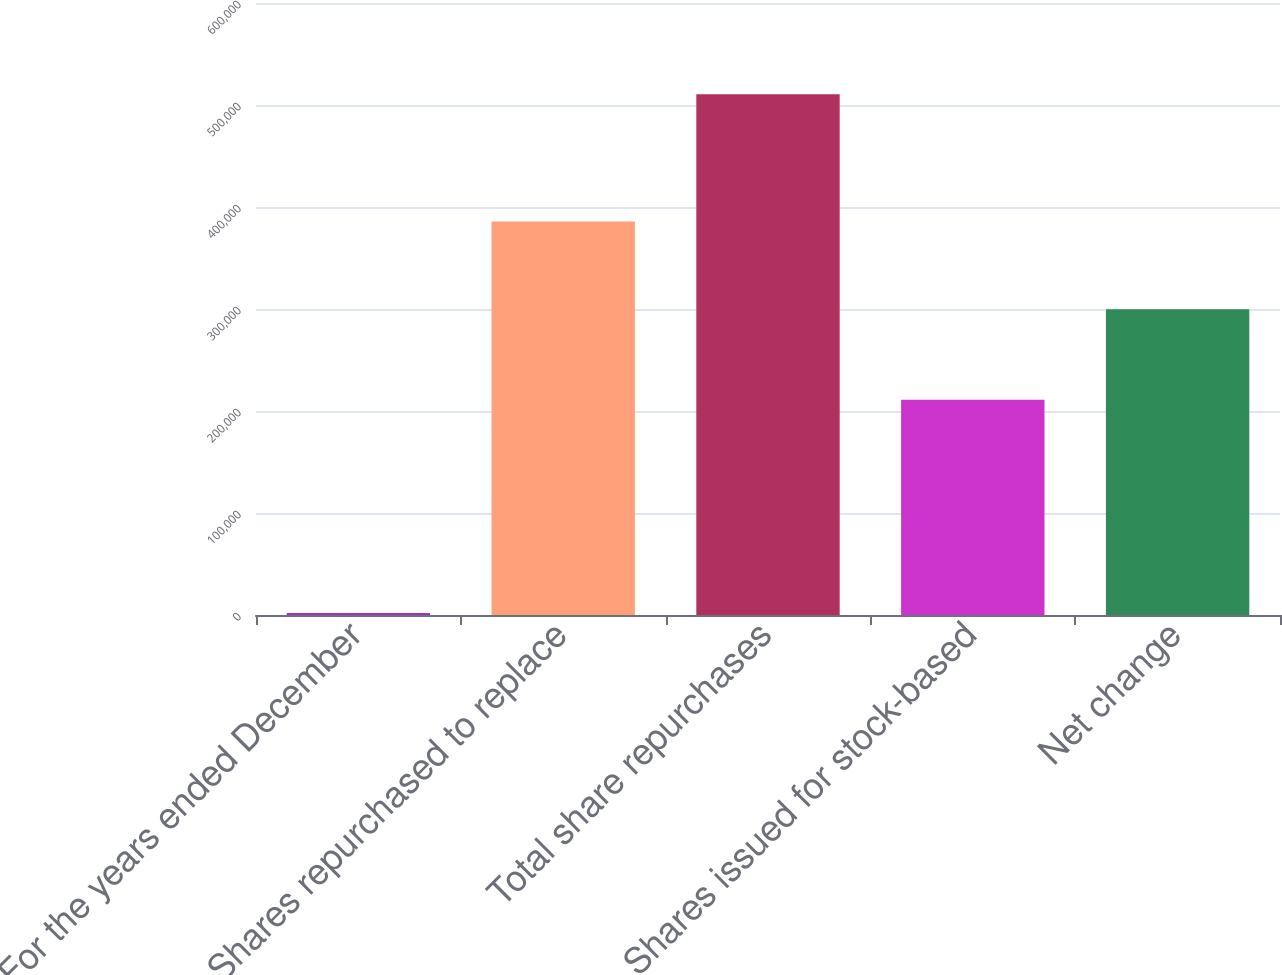Convert chart. <chart><loc_0><loc_0><loc_500><loc_500><bar_chart><fcel>For the years ended December<fcel>Shares repurchased to replace<fcel>Total share repurchases<fcel>Shares issued for stock-based<fcel>Net change<nl><fcel>2012<fcel>385699<fcel>510630<fcel>210924<fcel>299706<nl></chart> 